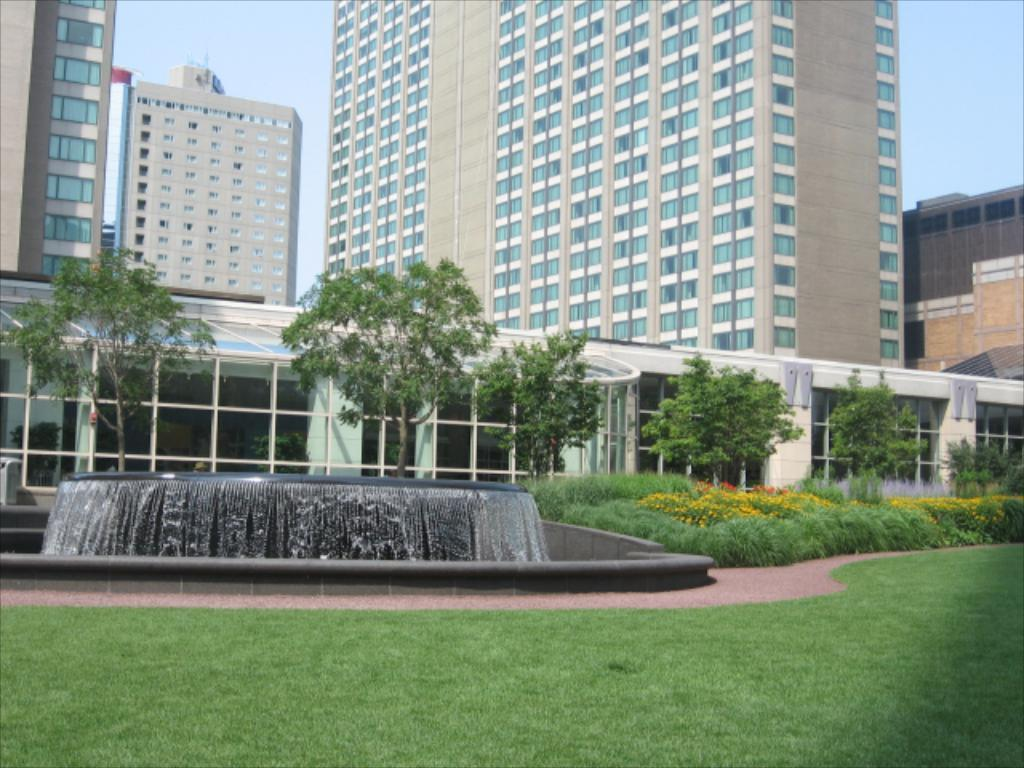What type of structures can be seen in the image? There are buildings in the image. What is located at the bottom of the image? There is a fountain and trees at the bottom of the image. What type of vegetation is present in the image? There is grass in the image. What can be seen in the background of the image? The sky is visible in the background of the image. Can you see any friends playing with a net in the image? There is no net or friends present in the image. What type of nut is visible in the image? There are no nuts present in the image. 